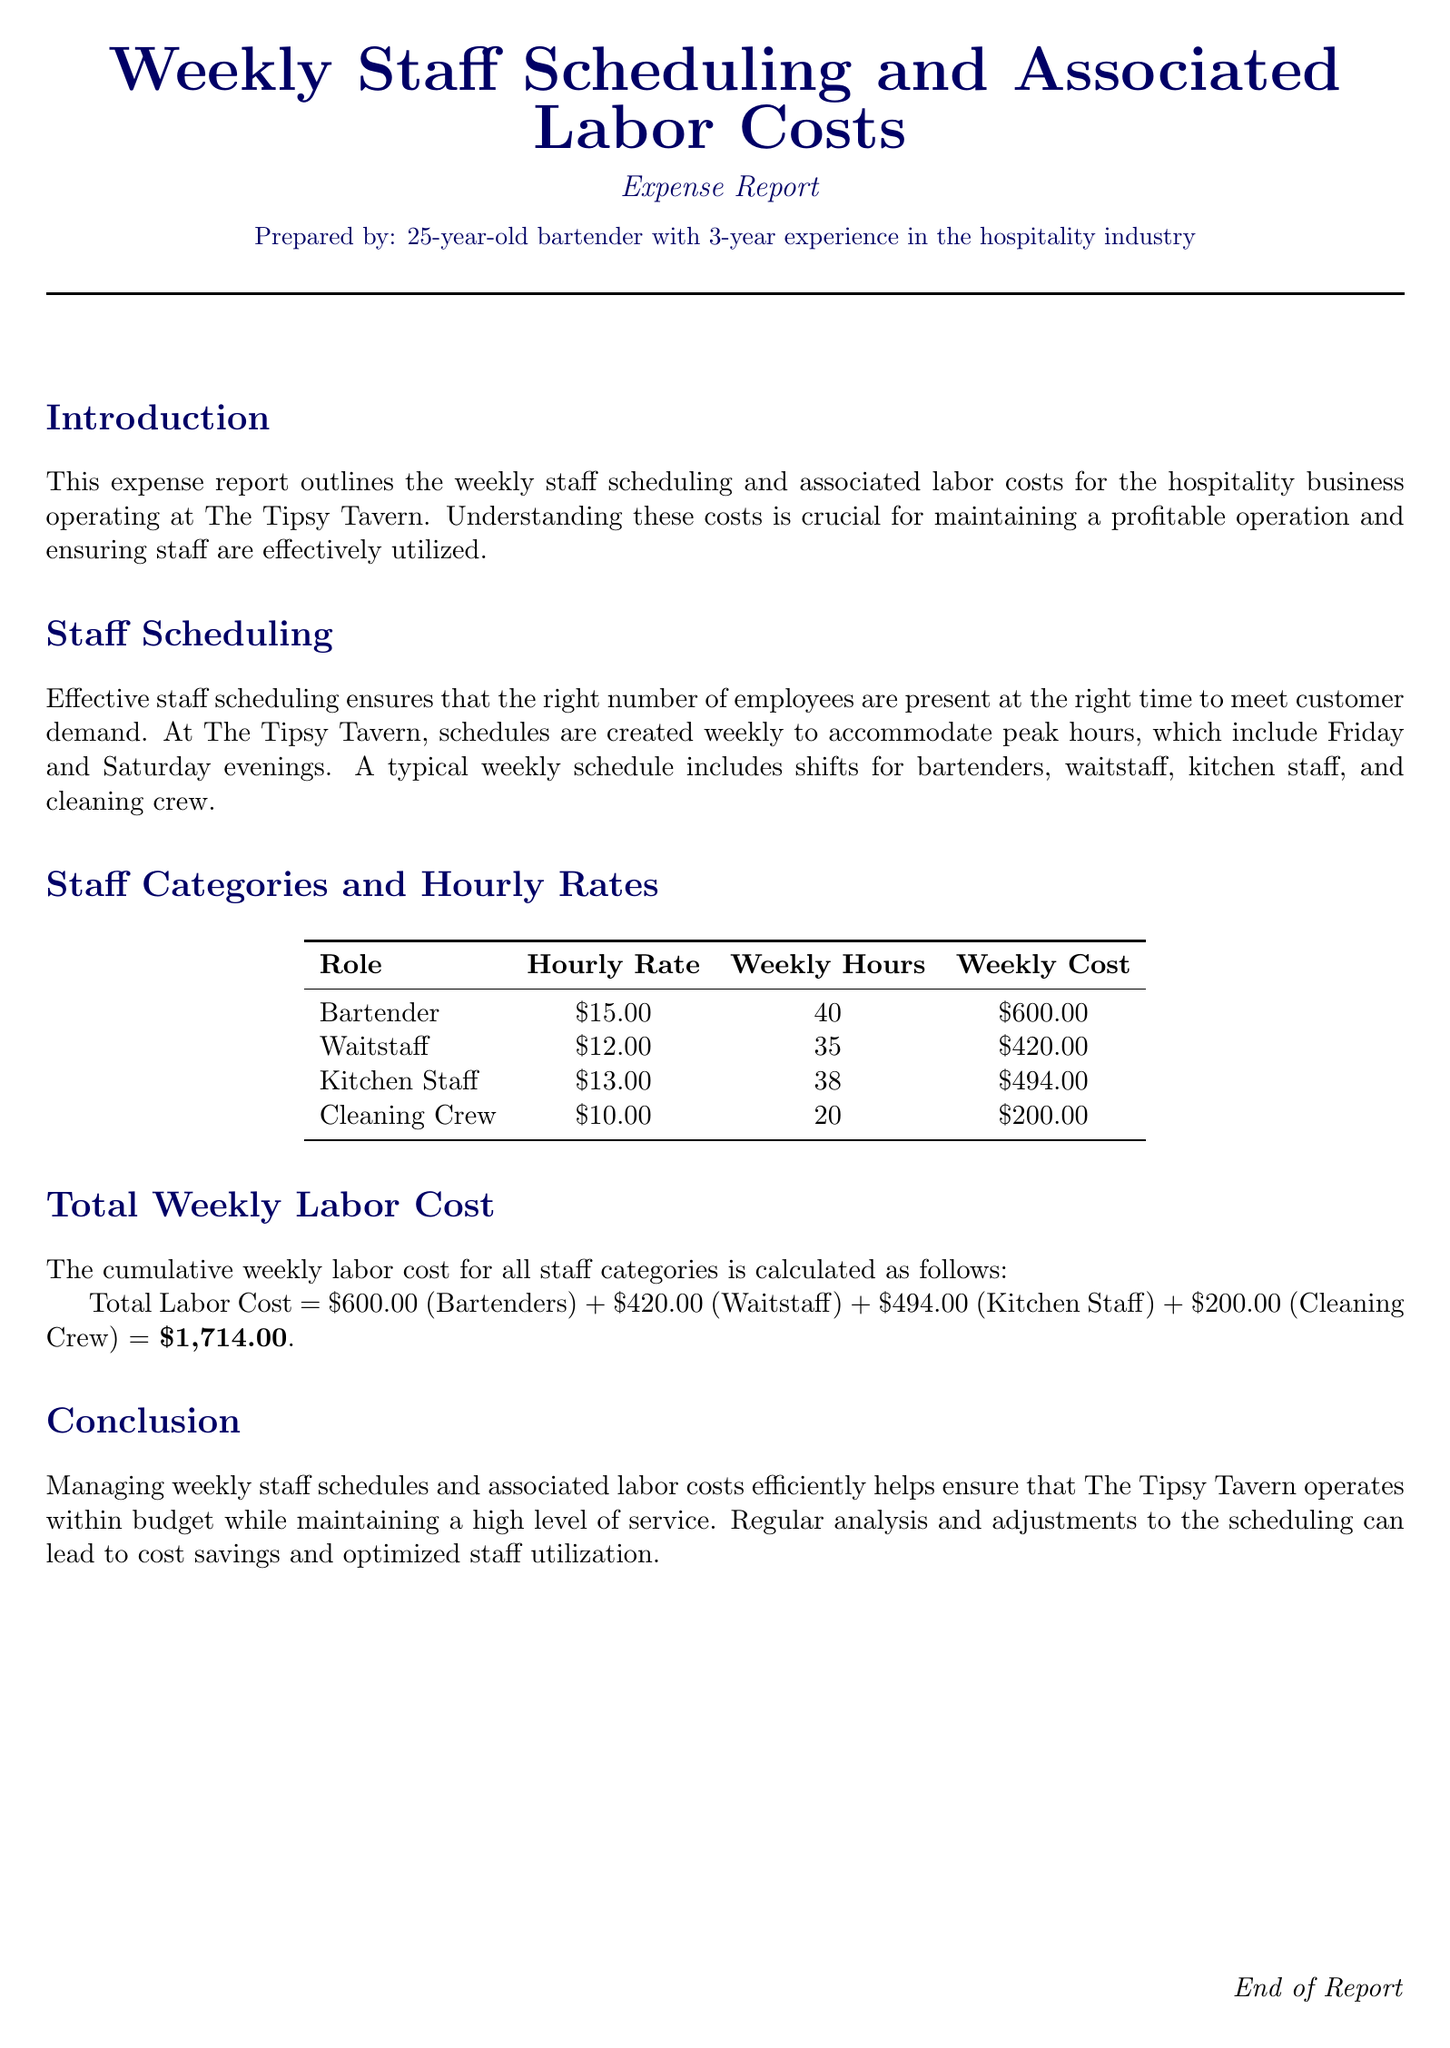What is the total weekly labor cost? The total weekly labor cost is calculated by adding the costs of each staff category, which results in $600.00 (Bartenders) + $420.00 (Waitstaff) + $494.00 (Kitchen Staff) + $200.00 (Cleaning Crew) = $1,714.00.
Answer: $1,714.00 How many hours do bartenders work weekly? The document indicates that bartenders work 40 hours weekly.
Answer: 40 What is the hourly rate for cleaning crew? The weekly staff scheduling table lists the hourly rate for the cleaning crew as $10.00.
Answer: $10.00 How many hours does kitchen staff work weekly? The document states that kitchen staff work 38 hours weekly.
Answer: 38 What is the total weekly cost for waitstaff? The total weekly cost for waitstaff is specified in the table as $420.00.
Answer: $420.00 Which day of the week has peak hours? The report mentions that peak hours are on Friday and Saturday evenings.
Answer: Friday and Saturday What is the average hourly rate of all staff categories? The average hourly rate can be calculated by averaging the rates: (15 + 12 + 13 + 10) / 4 = 12.5, but this average isn't explicitly provided in the document.
Answer: Not provided What role has the highest weekly cost? By examining the weekly costs, bartenders have the highest cost at $600.00.
Answer: Bartender What is the function of this expense report? The expense report serves to outline the weekly staff scheduling and associated labor costs for maintaining profitability.
Answer: Maintain profitability 